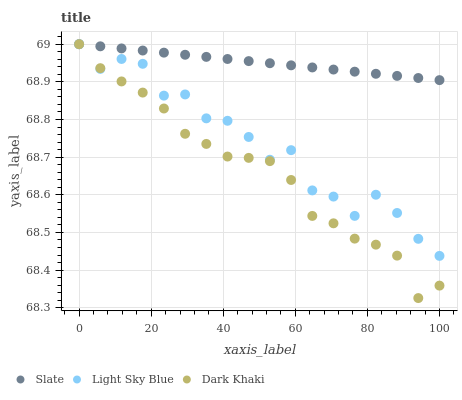Does Dark Khaki have the minimum area under the curve?
Answer yes or no. Yes. Does Slate have the maximum area under the curve?
Answer yes or no. Yes. Does Light Sky Blue have the minimum area under the curve?
Answer yes or no. No. Does Light Sky Blue have the maximum area under the curve?
Answer yes or no. No. Is Slate the smoothest?
Answer yes or no. Yes. Is Light Sky Blue the roughest?
Answer yes or no. Yes. Is Light Sky Blue the smoothest?
Answer yes or no. No. Is Slate the roughest?
Answer yes or no. No. Does Dark Khaki have the lowest value?
Answer yes or no. Yes. Does Light Sky Blue have the lowest value?
Answer yes or no. No. Does Light Sky Blue have the highest value?
Answer yes or no. Yes. Does Light Sky Blue intersect Slate?
Answer yes or no. Yes. Is Light Sky Blue less than Slate?
Answer yes or no. No. Is Light Sky Blue greater than Slate?
Answer yes or no. No. 